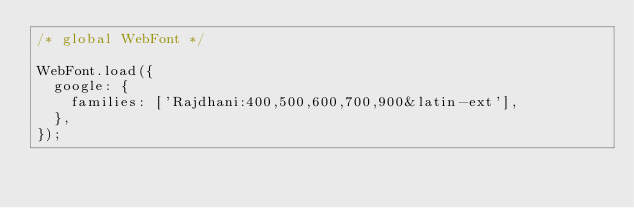Convert code to text. <code><loc_0><loc_0><loc_500><loc_500><_JavaScript_>/* global WebFont */

WebFont.load({
  google: {
    families: ['Rajdhani:400,500,600,700,900&latin-ext'],
  },
});
</code> 